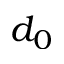Convert formula to latex. <formula><loc_0><loc_0><loc_500><loc_500>d _ { 0 }</formula> 